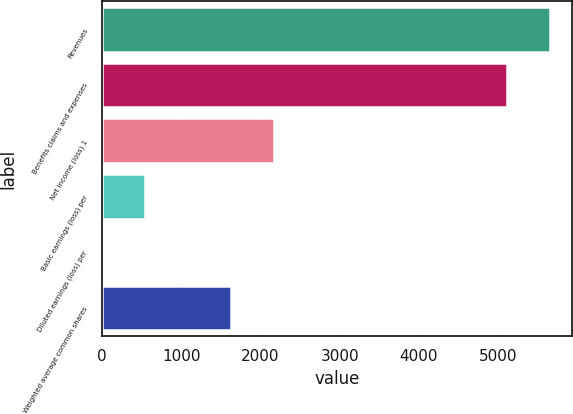<chart> <loc_0><loc_0><loc_500><loc_500><bar_chart><fcel>Revenues<fcel>Benefits claims and expenses<fcel>Net income (loss) 1<fcel>Basic earnings (loss) per<fcel>Diluted earnings (loss) per<fcel>Weighted average common shares<nl><fcel>5650.43<fcel>5109<fcel>2167.38<fcel>543.09<fcel>1.66<fcel>1625.95<nl></chart> 